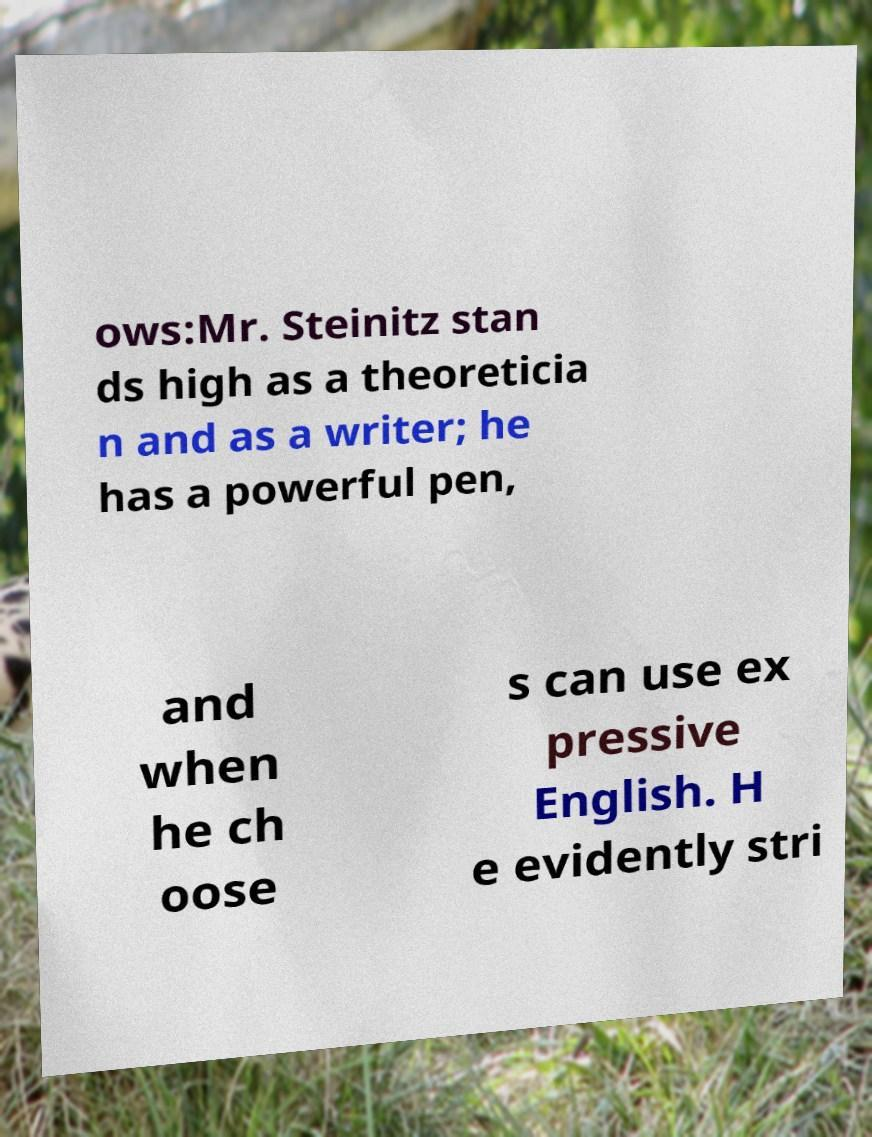Can you read and provide the text displayed in the image?This photo seems to have some interesting text. Can you extract and type it out for me? ows:Mr. Steinitz stan ds high as a theoreticia n and as a writer; he has a powerful pen, and when he ch oose s can use ex pressive English. H e evidently stri 